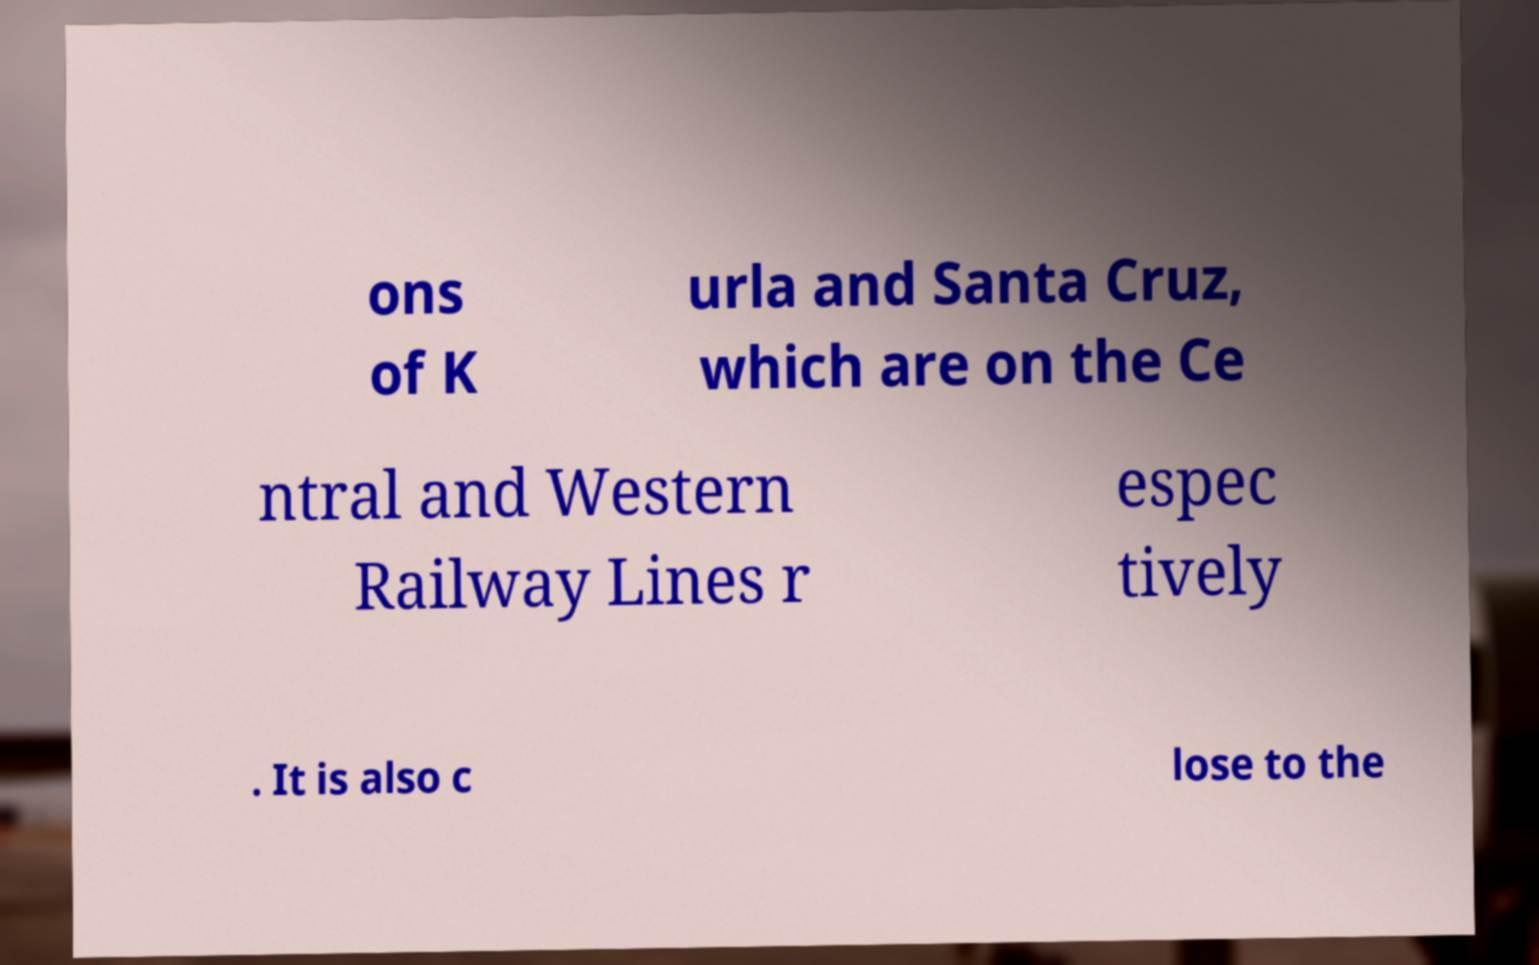I need the written content from this picture converted into text. Can you do that? ons of K urla and Santa Cruz, which are on the Ce ntral and Western Railway Lines r espec tively . It is also c lose to the 